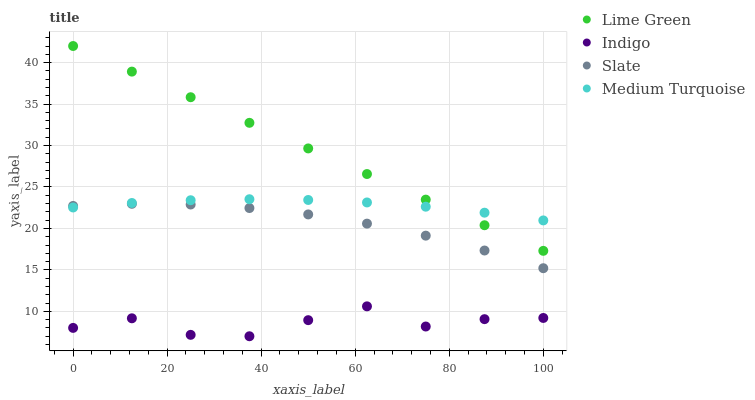Does Indigo have the minimum area under the curve?
Answer yes or no. Yes. Does Lime Green have the maximum area under the curve?
Answer yes or no. Yes. Does Slate have the minimum area under the curve?
Answer yes or no. No. Does Slate have the maximum area under the curve?
Answer yes or no. No. Is Lime Green the smoothest?
Answer yes or no. Yes. Is Indigo the roughest?
Answer yes or no. Yes. Is Slate the smoothest?
Answer yes or no. No. Is Slate the roughest?
Answer yes or no. No. Does Indigo have the lowest value?
Answer yes or no. Yes. Does Slate have the lowest value?
Answer yes or no. No. Does Lime Green have the highest value?
Answer yes or no. Yes. Does Slate have the highest value?
Answer yes or no. No. Is Indigo less than Medium Turquoise?
Answer yes or no. Yes. Is Slate greater than Indigo?
Answer yes or no. Yes. Does Slate intersect Medium Turquoise?
Answer yes or no. Yes. Is Slate less than Medium Turquoise?
Answer yes or no. No. Is Slate greater than Medium Turquoise?
Answer yes or no. No. Does Indigo intersect Medium Turquoise?
Answer yes or no. No. 